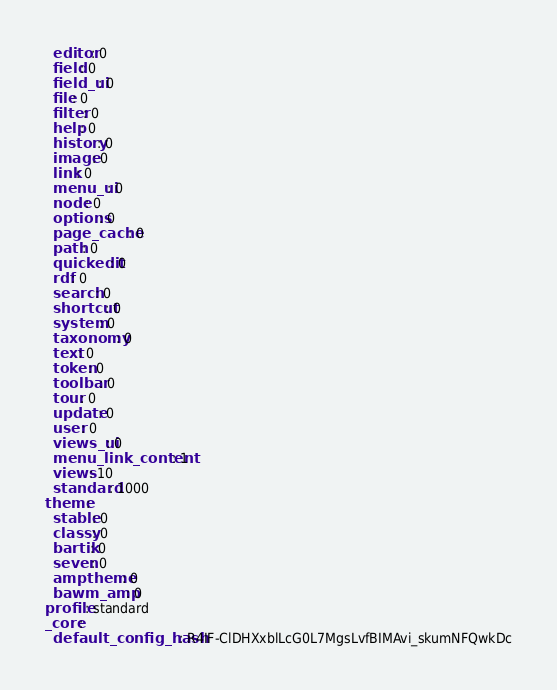<code> <loc_0><loc_0><loc_500><loc_500><_YAML_>  editor: 0
  field: 0
  field_ui: 0
  file: 0
  filter: 0
  help: 0
  history: 0
  image: 0
  link: 0
  menu_ui: 0
  node: 0
  options: 0
  page_cache: 0
  path: 0
  quickedit: 0
  rdf: 0
  search: 0
  shortcut: 0
  system: 0
  taxonomy: 0
  text: 0
  token: 0
  toolbar: 0
  tour: 0
  update: 0
  user: 0
  views_ui: 0
  menu_link_content: 1
  views: 10
  standard: 1000
theme:
  stable: 0
  classy: 0
  bartik: 0
  seven: 0
  amptheme: 0
  bawm_amp: 0
profile: standard
_core:
  default_config_hash: R4IF-ClDHXxblLcG0L7MgsLvfBIMAvi_skumNFQwkDc
</code> 